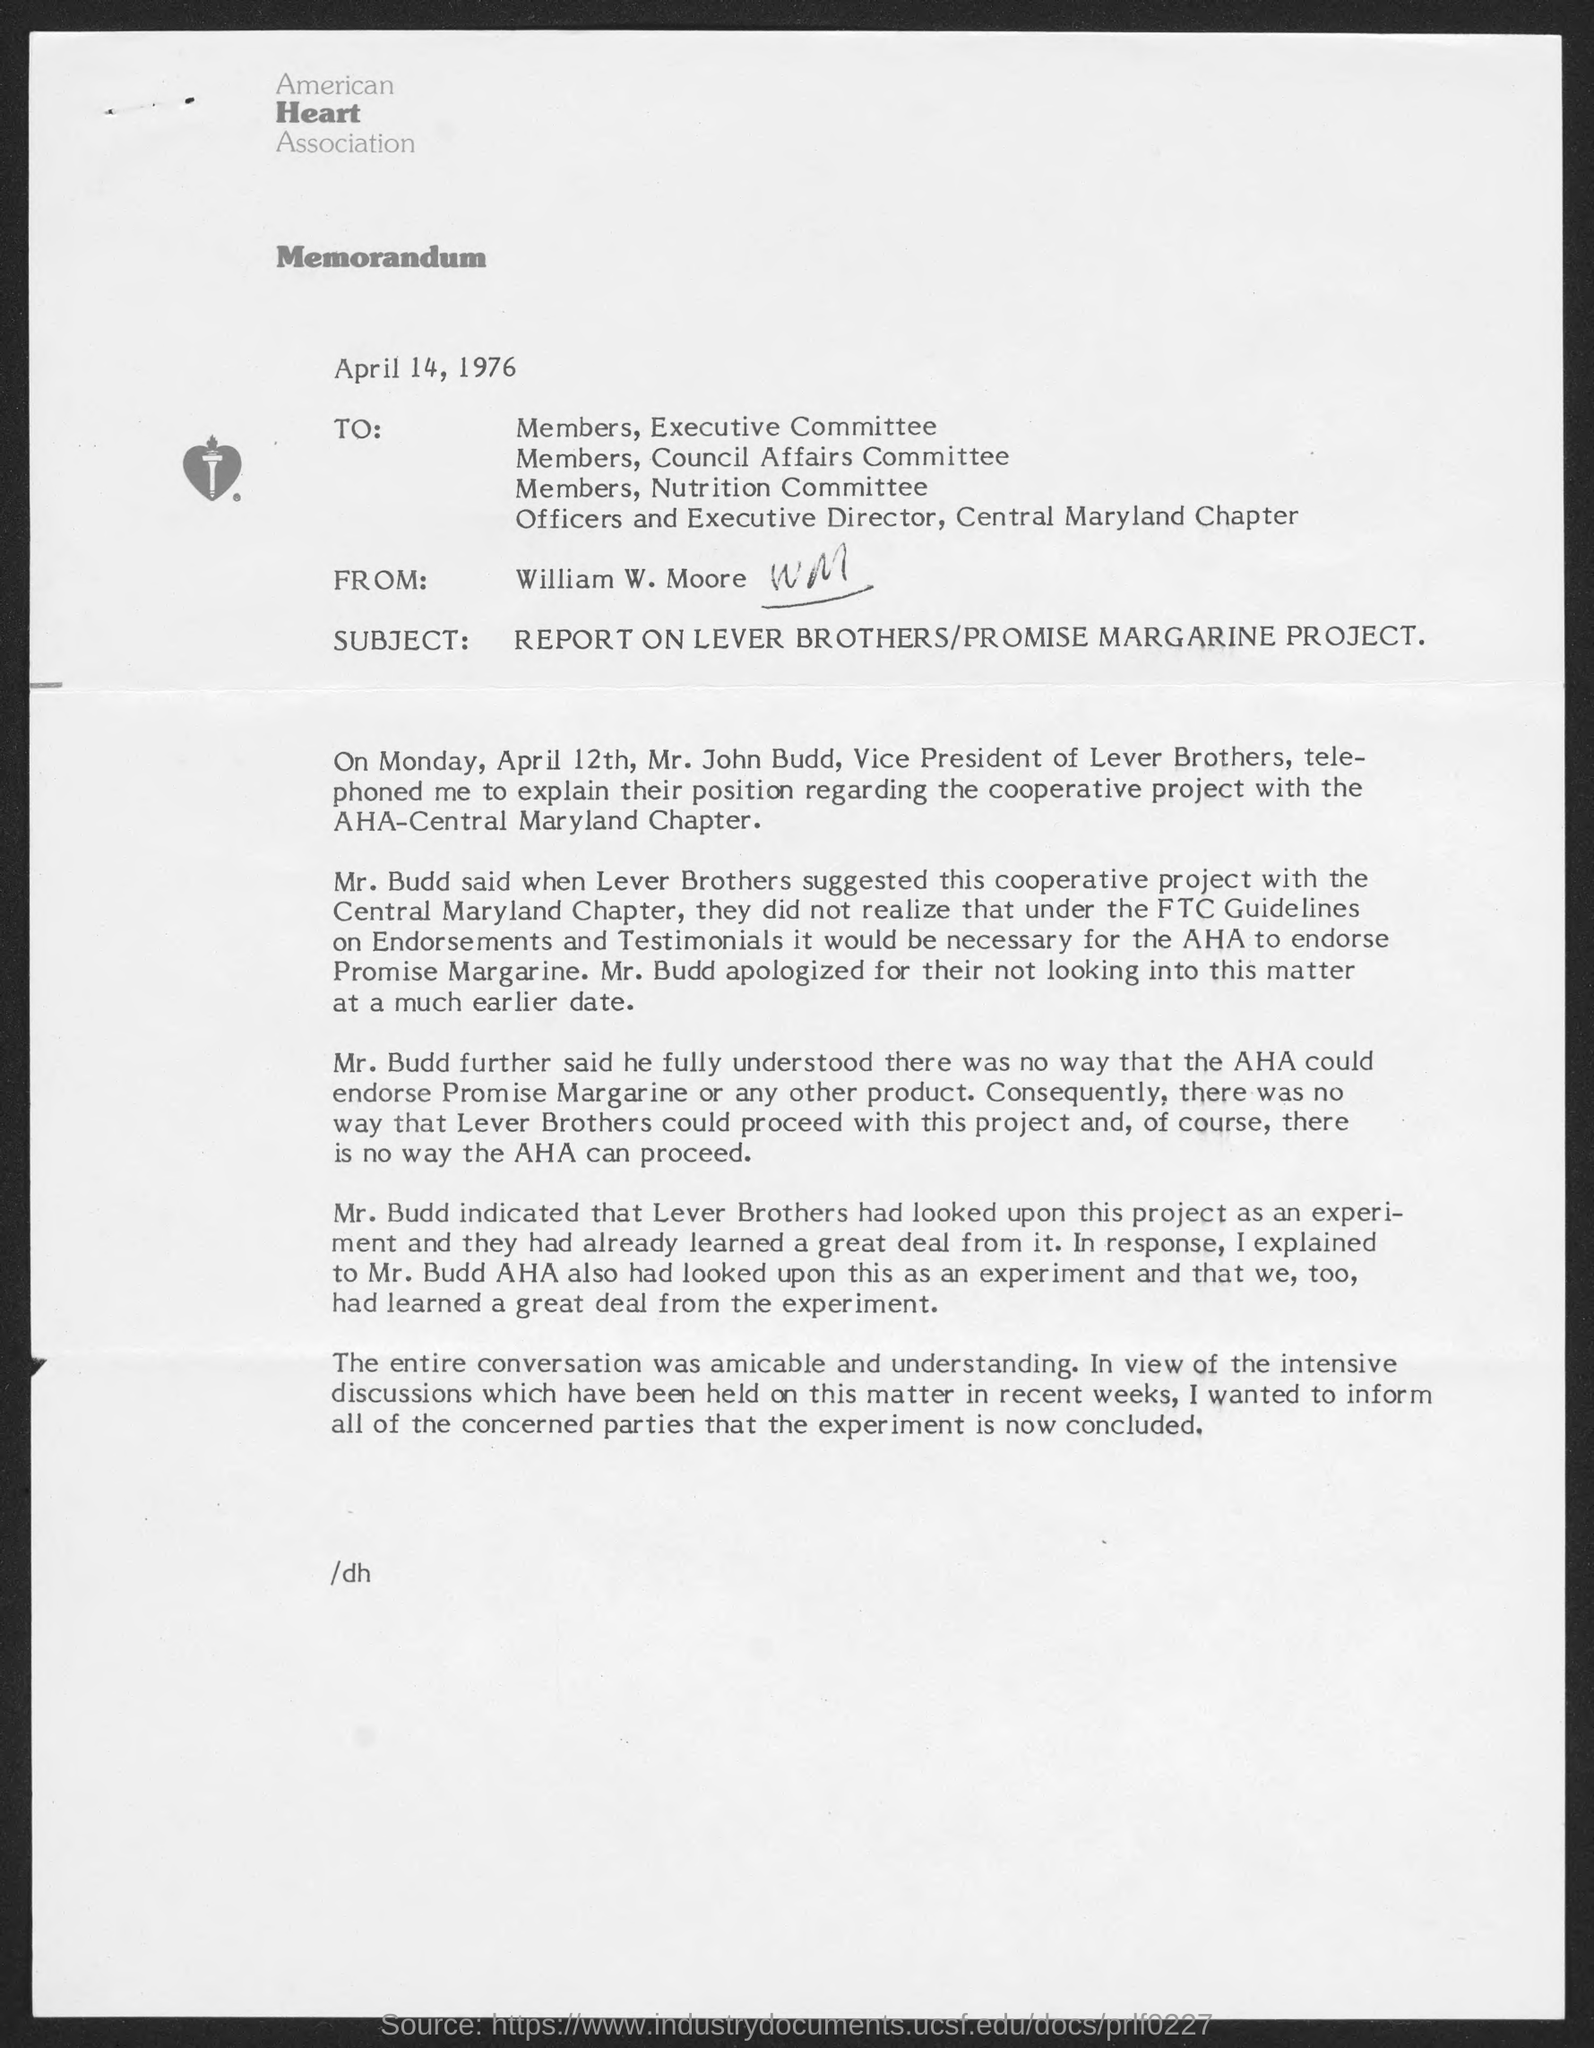Who wrote this memorandum ?
Give a very brief answer. William W. Moore. What is the name of the association ?
Keep it short and to the point. American Heart Association. What is the full-form of aha ?
Make the answer very short. American Heart Association. 